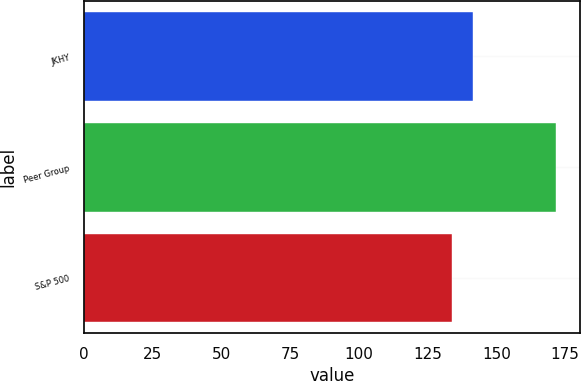<chart> <loc_0><loc_0><loc_500><loc_500><bar_chart><fcel>JKHY<fcel>Peer Group<fcel>S&P 500<nl><fcel>141.48<fcel>171.8<fcel>133.86<nl></chart> 